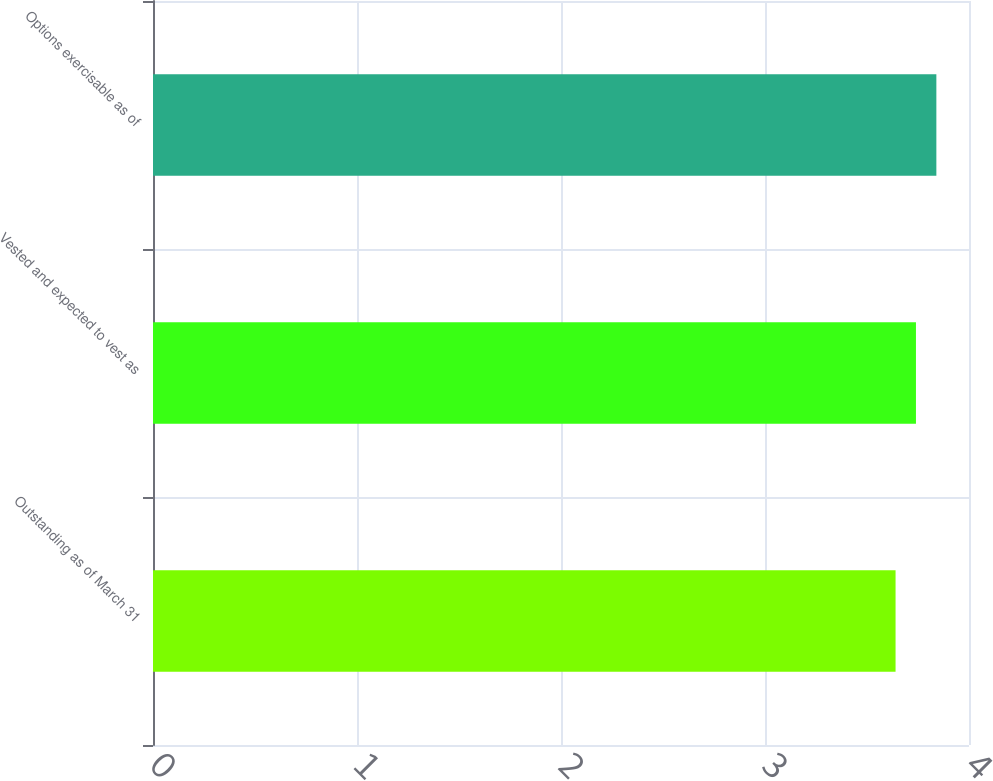Convert chart to OTSL. <chart><loc_0><loc_0><loc_500><loc_500><bar_chart><fcel>Outstanding as of March 31<fcel>Vested and expected to vest as<fcel>Options exercisable as of<nl><fcel>3.64<fcel>3.74<fcel>3.84<nl></chart> 